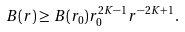<formula> <loc_0><loc_0><loc_500><loc_500>B ( r ) \geq B ( r _ { 0 } ) r _ { 0 } ^ { 2 K - 1 } r ^ { - 2 K + 1 } .</formula> 